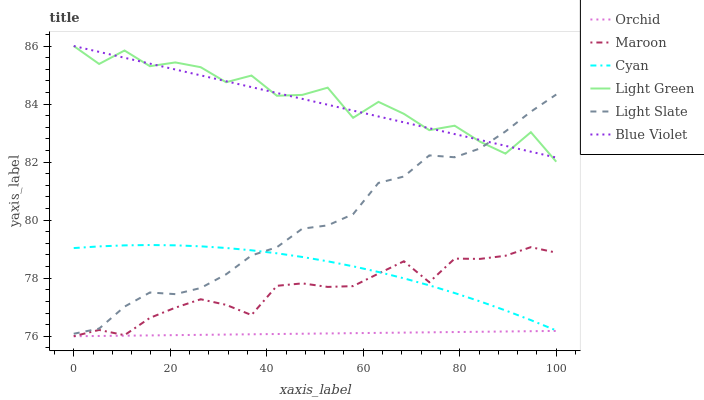Does Orchid have the minimum area under the curve?
Answer yes or no. Yes. Does Light Green have the maximum area under the curve?
Answer yes or no. Yes. Does Maroon have the minimum area under the curve?
Answer yes or no. No. Does Maroon have the maximum area under the curve?
Answer yes or no. No. Is Blue Violet the smoothest?
Answer yes or no. Yes. Is Light Green the roughest?
Answer yes or no. Yes. Is Maroon the smoothest?
Answer yes or no. No. Is Maroon the roughest?
Answer yes or no. No. Does Maroon have the lowest value?
Answer yes or no. Yes. Does Light Green have the lowest value?
Answer yes or no. No. Does Blue Violet have the highest value?
Answer yes or no. Yes. Does Maroon have the highest value?
Answer yes or no. No. Is Maroon less than Blue Violet?
Answer yes or no. Yes. Is Light Slate greater than Orchid?
Answer yes or no. Yes. Does Light Slate intersect Cyan?
Answer yes or no. Yes. Is Light Slate less than Cyan?
Answer yes or no. No. Is Light Slate greater than Cyan?
Answer yes or no. No. Does Maroon intersect Blue Violet?
Answer yes or no. No. 